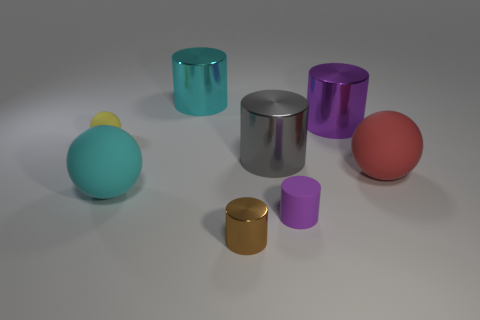How do the different textures of the objects contribute to the overall feel of the image? The interplay of textures in the image creates a dynamic contrast. The matte surfaces absorb light, lending a softness to their appearance, whereas the reflective objects create sharp highlights and mirrored details, adding a sense of complexity and realism to the setting. 